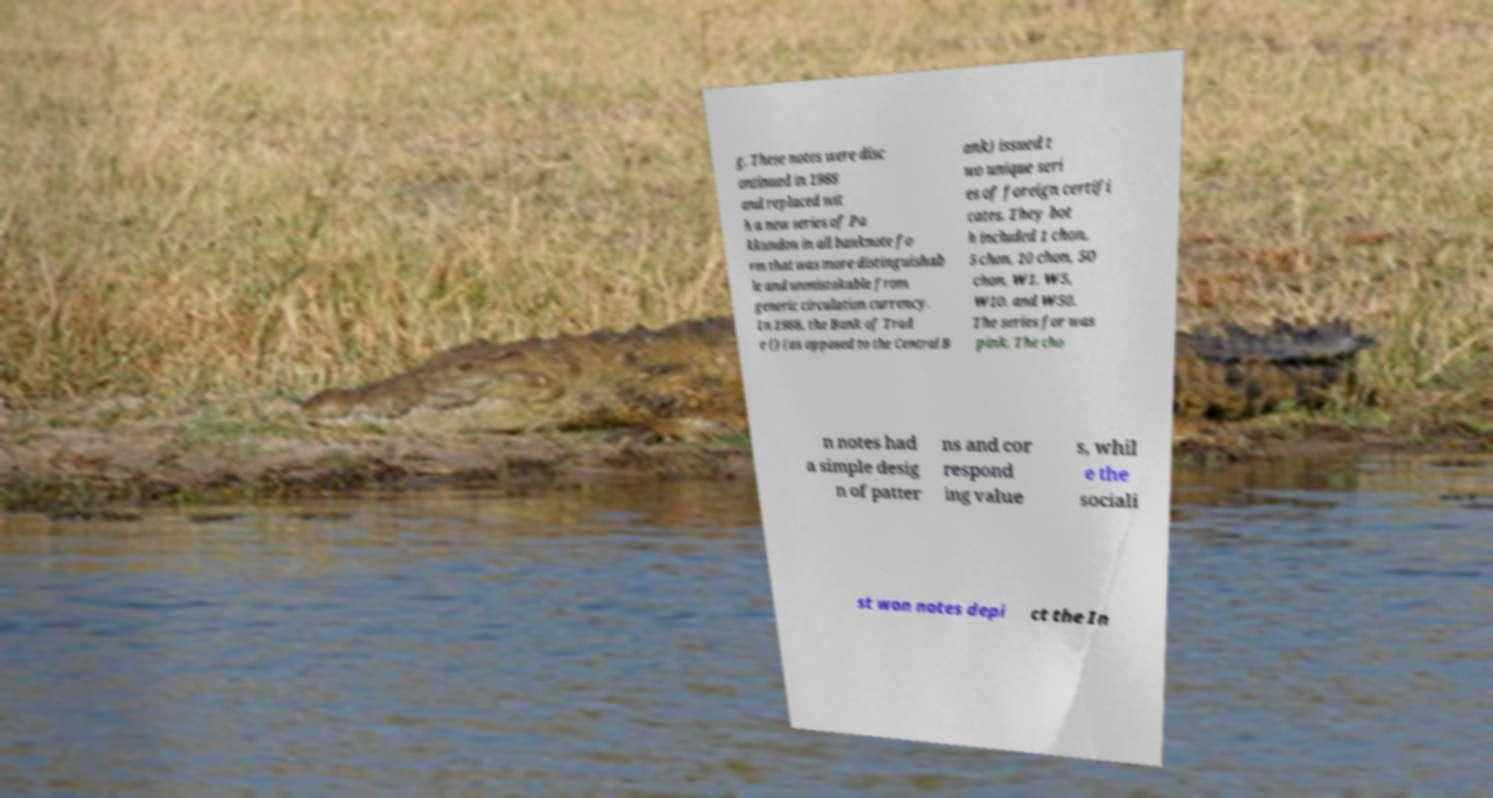Could you extract and type out the text from this image? g. These notes were disc ontinued in 1988 and replaced wit h a new series of Pa kkundon in all banknote fo rm that was more distinguishab le and unmistakable from generic circulation currency. In 1988, the Bank of Trad e () (as opposed to the Central B ank) issued t wo unique seri es of foreign certifi cates. They bot h included 1 chon, 5 chon, 10 chon, 50 chon, ₩1, ₩5, ₩10, and ₩50. The series for was pink. The cho n notes had a simple desig n of patter ns and cor respond ing value s, whil e the sociali st won notes depi ct the In 